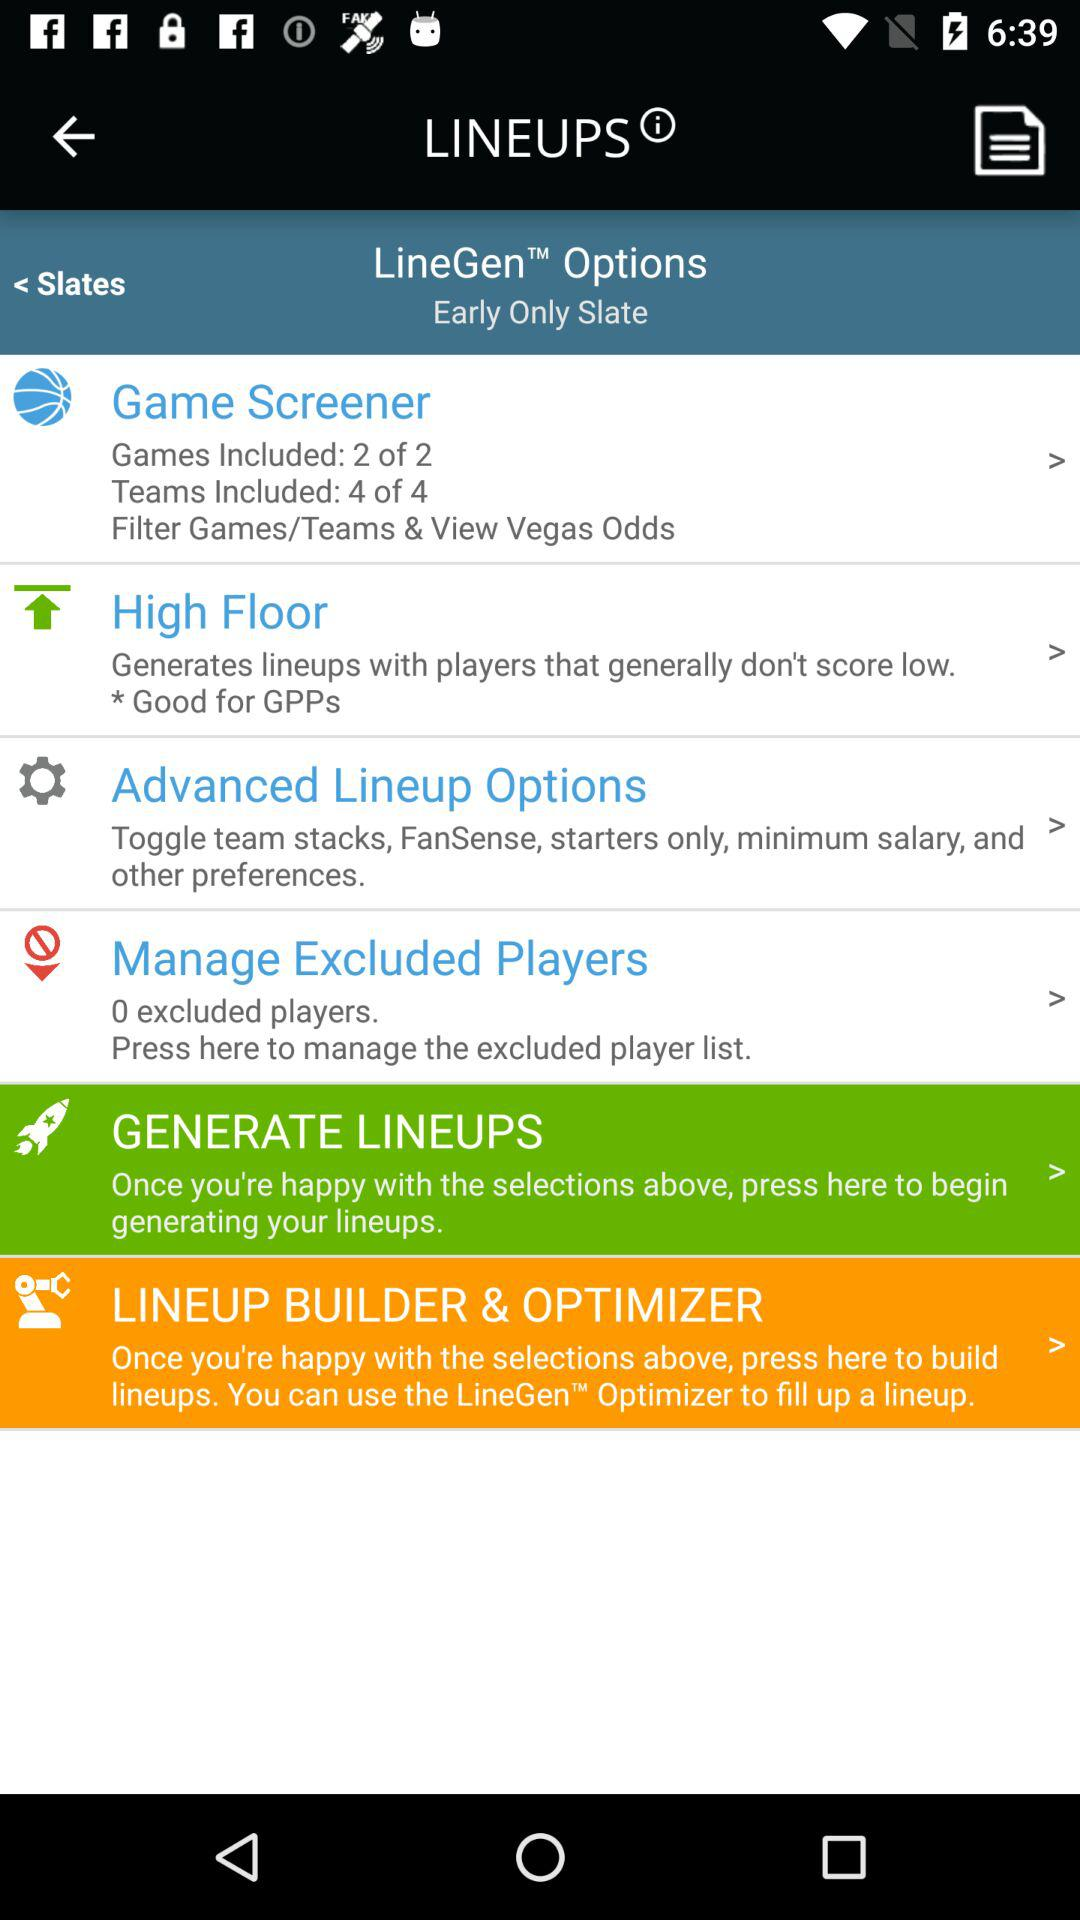How many games are included in "Game Screener"? There are 2 games included in "Game Screener". 